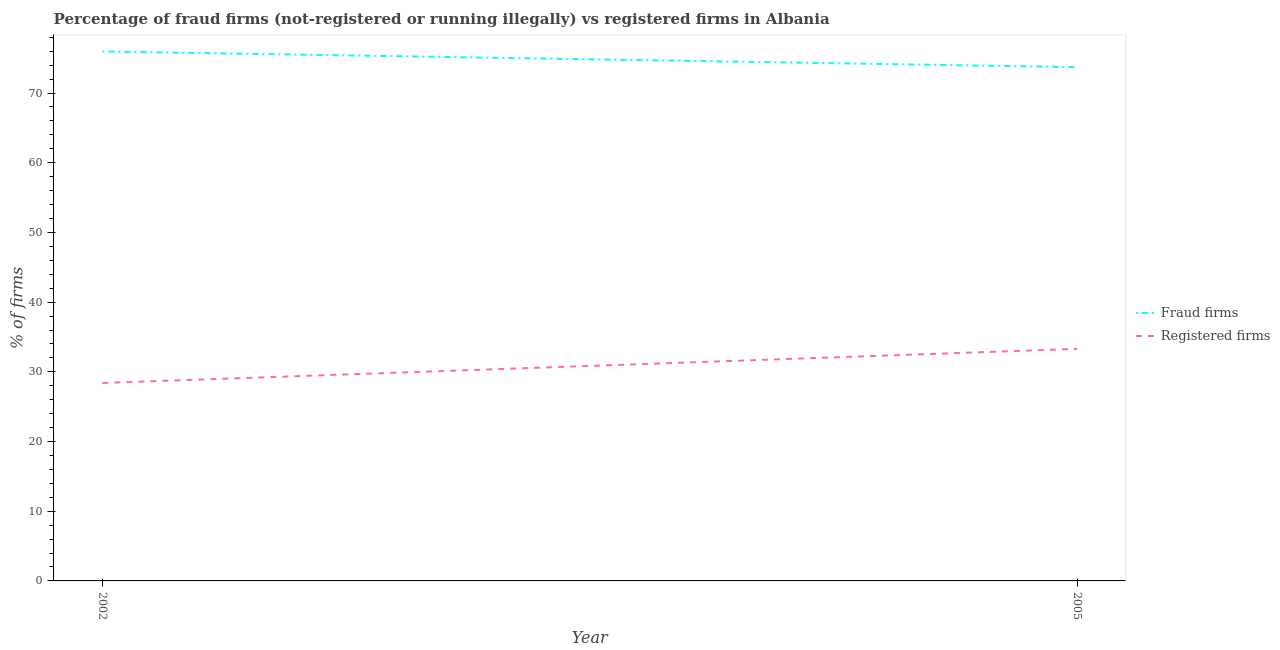How many different coloured lines are there?
Ensure brevity in your answer.  2. Does the line corresponding to percentage of fraud firms intersect with the line corresponding to percentage of registered firms?
Ensure brevity in your answer.  No. Is the number of lines equal to the number of legend labels?
Your response must be concise. Yes. What is the percentage of registered firms in 2005?
Provide a short and direct response. 33.3. Across all years, what is the maximum percentage of registered firms?
Ensure brevity in your answer.  33.3. Across all years, what is the minimum percentage of registered firms?
Your response must be concise. 28.4. In which year was the percentage of registered firms minimum?
Offer a terse response. 2002. What is the total percentage of registered firms in the graph?
Provide a short and direct response. 61.7. What is the difference between the percentage of registered firms in 2002 and that in 2005?
Provide a short and direct response. -4.9. What is the difference between the percentage of registered firms in 2005 and the percentage of fraud firms in 2002?
Offer a terse response. -42.67. What is the average percentage of fraud firms per year?
Keep it short and to the point. 74.84. In the year 2005, what is the difference between the percentage of registered firms and percentage of fraud firms?
Give a very brief answer. -40.42. In how many years, is the percentage of registered firms greater than 34 %?
Ensure brevity in your answer.  0. What is the ratio of the percentage of fraud firms in 2002 to that in 2005?
Keep it short and to the point. 1.03. Is the percentage of fraud firms in 2002 less than that in 2005?
Make the answer very short. No. Does the percentage of registered firms monotonically increase over the years?
Your response must be concise. Yes. Is the percentage of registered firms strictly less than the percentage of fraud firms over the years?
Provide a succinct answer. Yes. What is the difference between two consecutive major ticks on the Y-axis?
Make the answer very short. 10. Are the values on the major ticks of Y-axis written in scientific E-notation?
Give a very brief answer. No. Does the graph contain any zero values?
Your answer should be very brief. No. How many legend labels are there?
Offer a very short reply. 2. What is the title of the graph?
Your response must be concise. Percentage of fraud firms (not-registered or running illegally) vs registered firms in Albania. What is the label or title of the Y-axis?
Offer a terse response. % of firms. What is the % of firms of Fraud firms in 2002?
Provide a short and direct response. 75.97. What is the % of firms in Registered firms in 2002?
Keep it short and to the point. 28.4. What is the % of firms of Fraud firms in 2005?
Make the answer very short. 73.72. What is the % of firms in Registered firms in 2005?
Your answer should be compact. 33.3. Across all years, what is the maximum % of firms in Fraud firms?
Offer a very short reply. 75.97. Across all years, what is the maximum % of firms of Registered firms?
Make the answer very short. 33.3. Across all years, what is the minimum % of firms in Fraud firms?
Offer a very short reply. 73.72. Across all years, what is the minimum % of firms of Registered firms?
Offer a very short reply. 28.4. What is the total % of firms of Fraud firms in the graph?
Offer a very short reply. 149.69. What is the total % of firms of Registered firms in the graph?
Your response must be concise. 61.7. What is the difference between the % of firms in Fraud firms in 2002 and that in 2005?
Keep it short and to the point. 2.25. What is the difference between the % of firms of Registered firms in 2002 and that in 2005?
Provide a succinct answer. -4.9. What is the difference between the % of firms of Fraud firms in 2002 and the % of firms of Registered firms in 2005?
Your response must be concise. 42.67. What is the average % of firms of Fraud firms per year?
Your answer should be compact. 74.84. What is the average % of firms in Registered firms per year?
Keep it short and to the point. 30.85. In the year 2002, what is the difference between the % of firms of Fraud firms and % of firms of Registered firms?
Ensure brevity in your answer.  47.57. In the year 2005, what is the difference between the % of firms of Fraud firms and % of firms of Registered firms?
Give a very brief answer. 40.42. What is the ratio of the % of firms of Fraud firms in 2002 to that in 2005?
Make the answer very short. 1.03. What is the ratio of the % of firms of Registered firms in 2002 to that in 2005?
Offer a very short reply. 0.85. What is the difference between the highest and the second highest % of firms of Fraud firms?
Your answer should be very brief. 2.25. What is the difference between the highest and the lowest % of firms of Fraud firms?
Your answer should be compact. 2.25. 